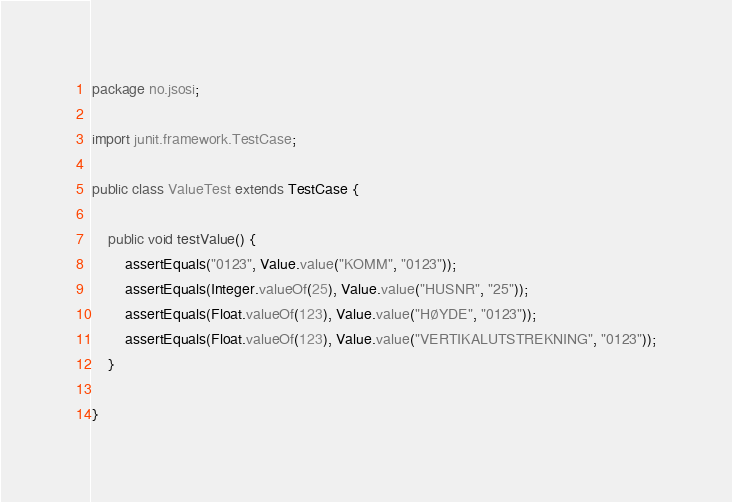<code> <loc_0><loc_0><loc_500><loc_500><_Java_>package no.jsosi;

import junit.framework.TestCase;

public class ValueTest extends TestCase {

    public void testValue() {
        assertEquals("0123", Value.value("KOMM", "0123"));
        assertEquals(Integer.valueOf(25), Value.value("HUSNR", "25"));
        assertEquals(Float.valueOf(123), Value.value("HØYDE", "0123"));
        assertEquals(Float.valueOf(123), Value.value("VERTIKALUTSTREKNING", "0123"));
    }

}
</code> 